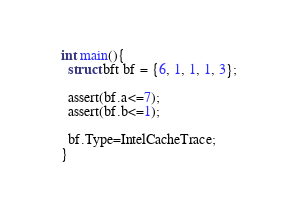<code> <loc_0><loc_0><loc_500><loc_500><_C_>int main(){
  struct bft bf = {6, 1, 1, 1, 3};
   
  assert(bf.a<=7);
  assert(bf.b<=1);
  
  bf.Type=IntelCacheTrace;
}
</code> 